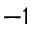Convert formula to latex. <formula><loc_0><loc_0><loc_500><loc_500>^ { - 1 }</formula> 